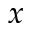Convert formula to latex. <formula><loc_0><loc_0><loc_500><loc_500>x</formula> 